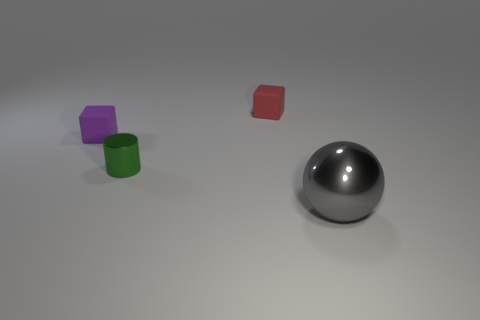Add 1 large matte spheres. How many objects exist? 5 Subtract all balls. How many objects are left? 3 Subtract all brown metal objects. Subtract all green objects. How many objects are left? 3 Add 3 shiny objects. How many shiny objects are left? 5 Add 1 small blue rubber balls. How many small blue rubber balls exist? 1 Subtract 0 yellow cylinders. How many objects are left? 4 